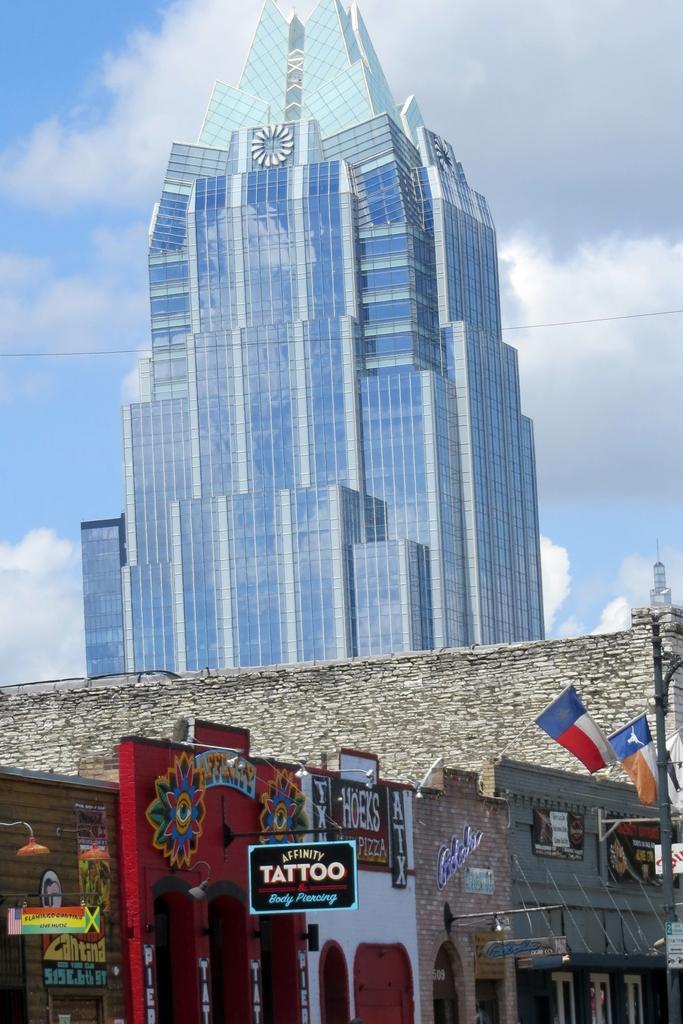Can you describe this image briefly? In this image I can see few stalls and I can also see flags, light poles. In the background I can see the glass building and the sky is in blue and white color. 